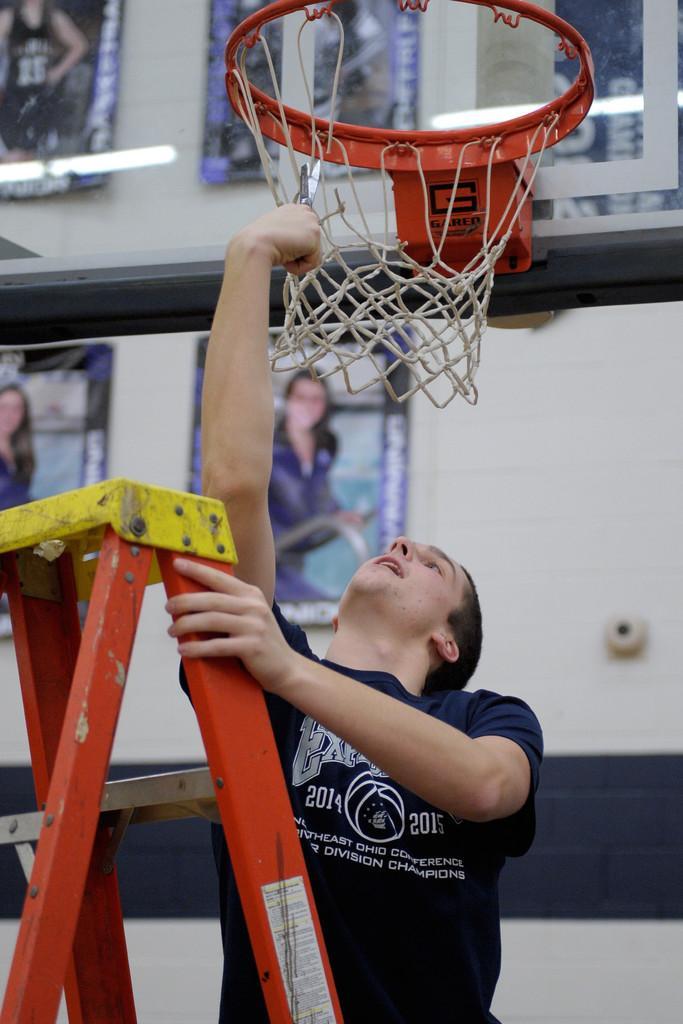Please provide a concise description of this image. In this picture I can see the ladder in front and I see a man who is holding it and I see that holding a net which is of a basket. In the background I see the wall on which there are few photo frames. 